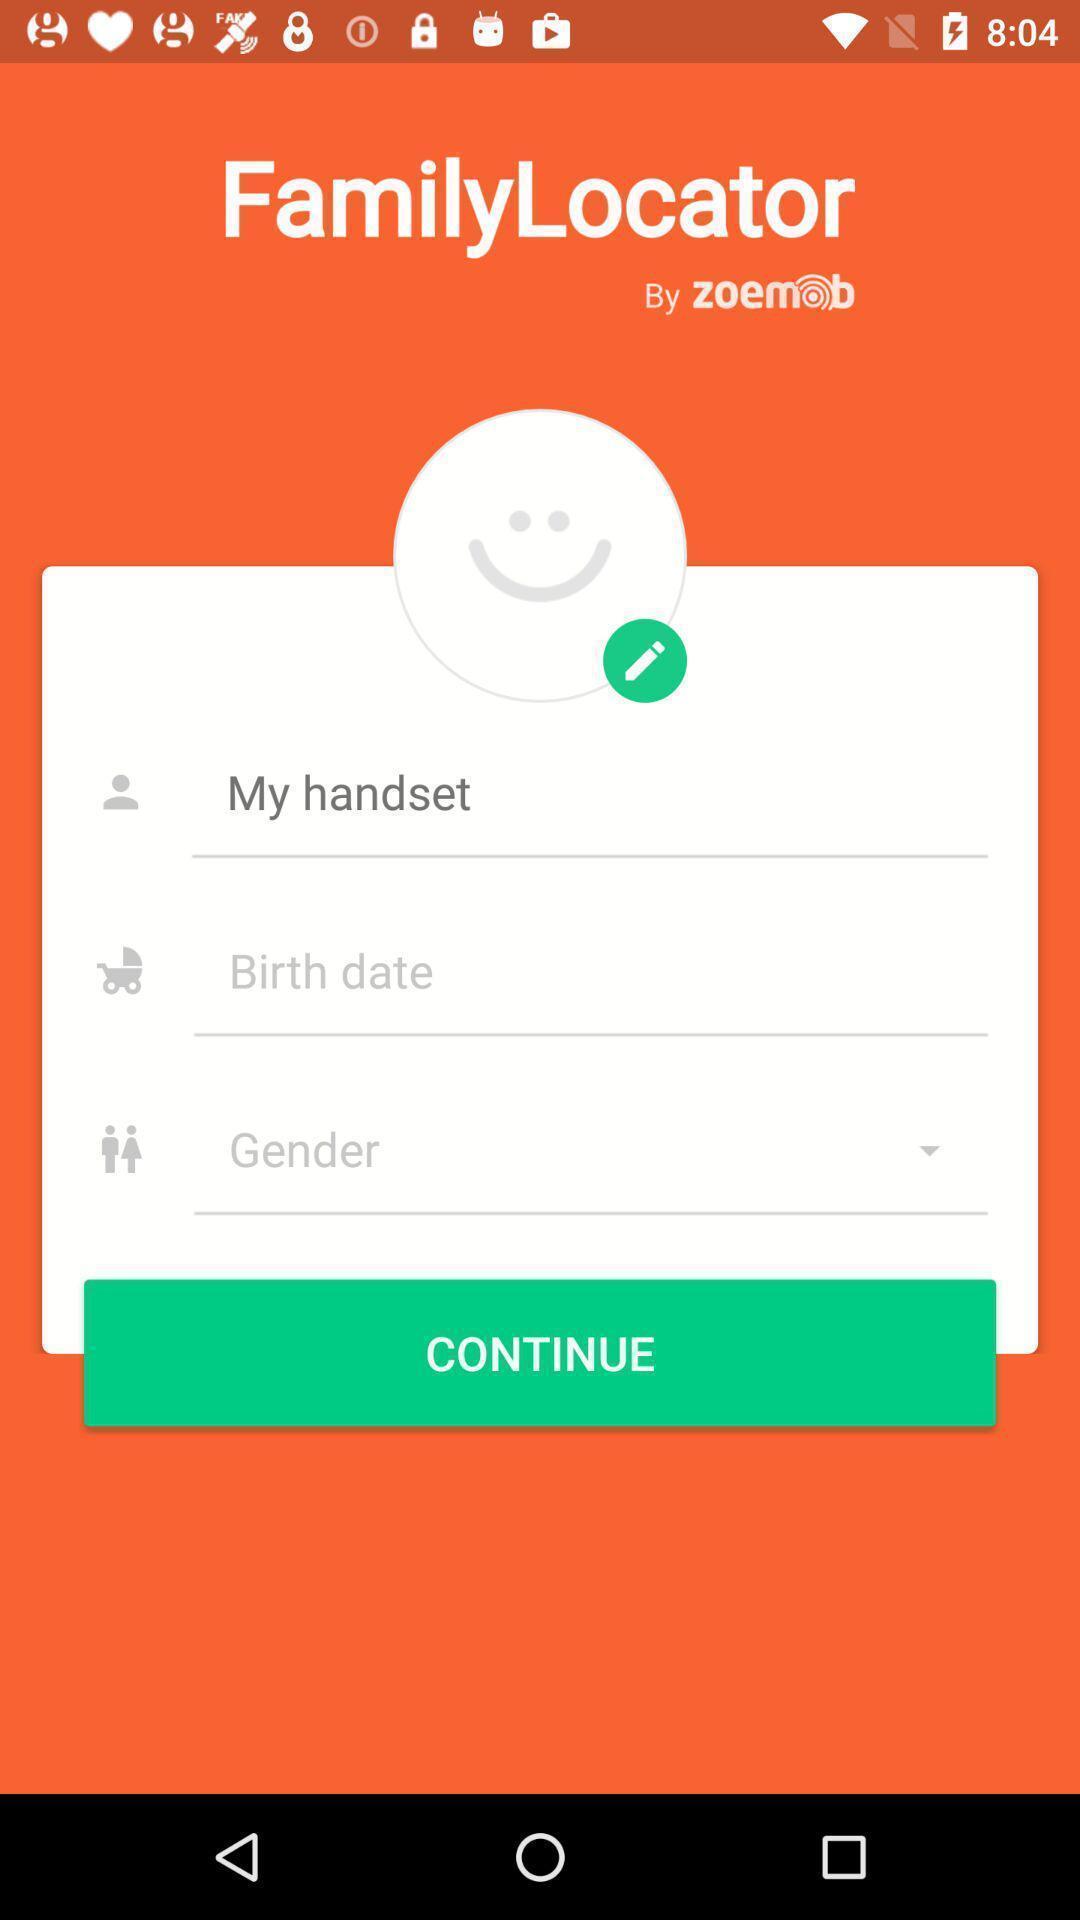Tell me about the visual elements in this screen capture. Profile page. 